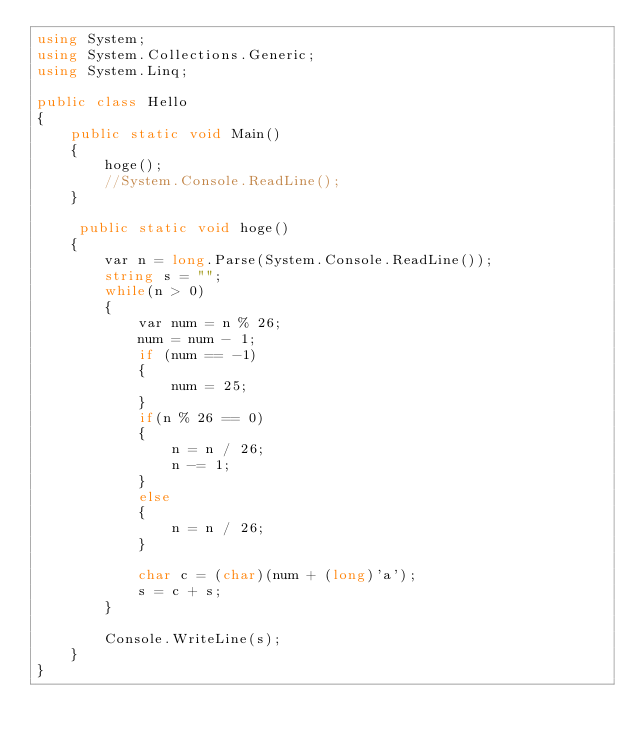Convert code to text. <code><loc_0><loc_0><loc_500><loc_500><_C#_>using System;
using System.Collections.Generic;
using System.Linq;

public class Hello
{
    public static void Main()
    {
        hoge();
        //System.Console.ReadLine();
    }

     public static void hoge()
    {
        var n = long.Parse(System.Console.ReadLine());
        string s = "";
        while(n > 0)
        {
            var num = n % 26;
            num = num - 1;
            if (num == -1)
            {
                num = 25;
            }
            if(n % 26 == 0)
            {
                n = n / 26;
                n -= 1;
            }
            else
            {
                n = n / 26;
            }
            
            char c = (char)(num + (long)'a');
            s = c + s;
        }

        Console.WriteLine(s);
    }
}</code> 